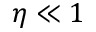<formula> <loc_0><loc_0><loc_500><loc_500>\eta \ll 1</formula> 